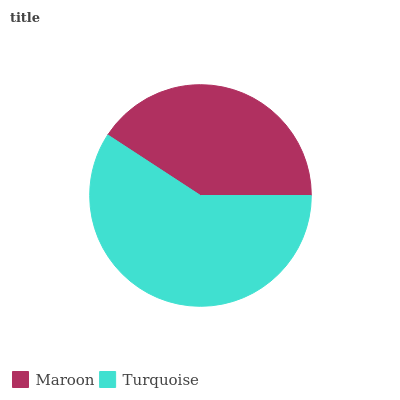Is Maroon the minimum?
Answer yes or no. Yes. Is Turquoise the maximum?
Answer yes or no. Yes. Is Turquoise the minimum?
Answer yes or no. No. Is Turquoise greater than Maroon?
Answer yes or no. Yes. Is Maroon less than Turquoise?
Answer yes or no. Yes. Is Maroon greater than Turquoise?
Answer yes or no. No. Is Turquoise less than Maroon?
Answer yes or no. No. Is Turquoise the high median?
Answer yes or no. Yes. Is Maroon the low median?
Answer yes or no. Yes. Is Maroon the high median?
Answer yes or no. No. Is Turquoise the low median?
Answer yes or no. No. 